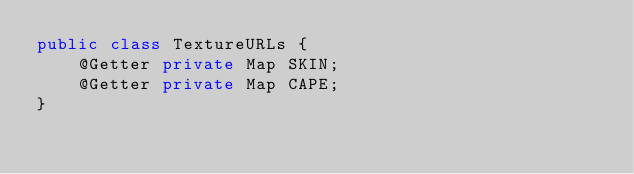Convert code to text. <code><loc_0><loc_0><loc_500><loc_500><_Java_>public class TextureURLs {
    @Getter private Map SKIN;
    @Getter private Map CAPE;
}
</code> 